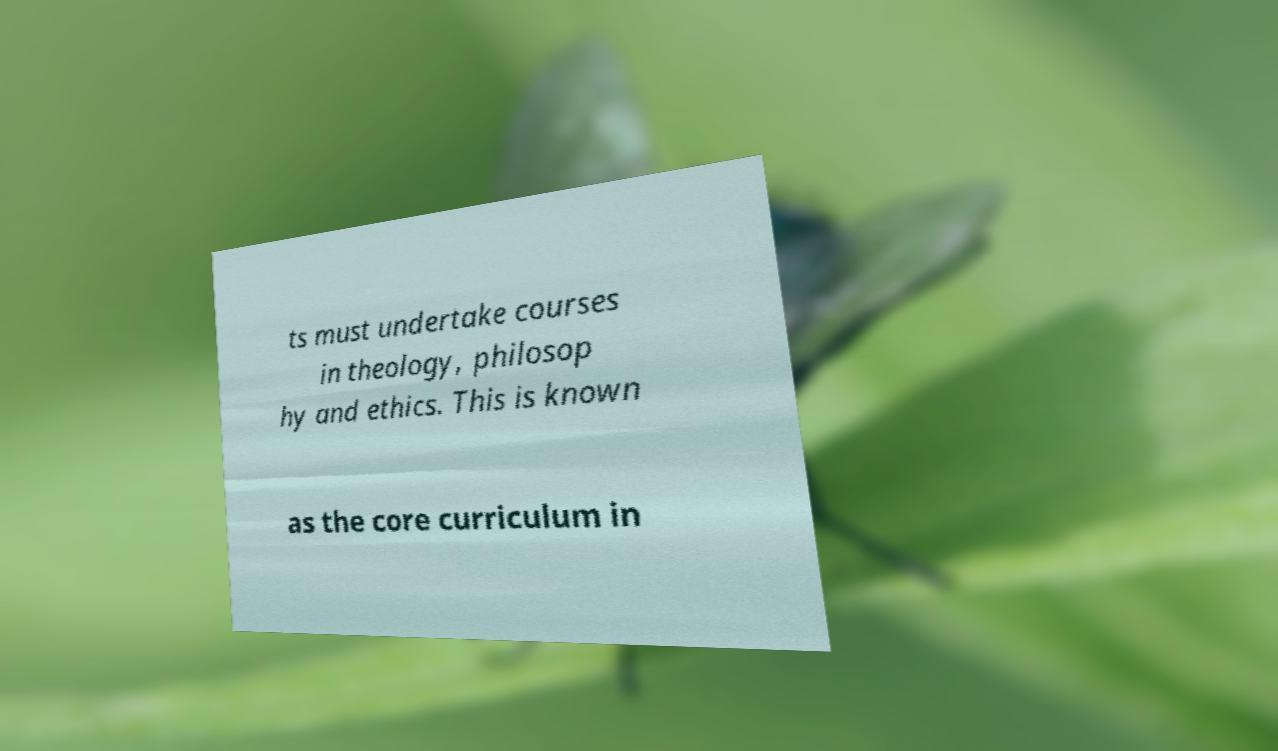Could you extract and type out the text from this image? ts must undertake courses in theology, philosop hy and ethics. This is known as the core curriculum in 